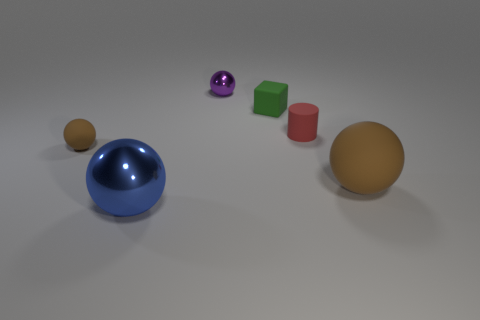Subtract all large shiny spheres. How many spheres are left? 3 Add 1 purple matte objects. How many objects exist? 7 Subtract all blue balls. How many balls are left? 3 Subtract 1 spheres. How many spheres are left? 3 Subtract 0 gray cylinders. How many objects are left? 6 Subtract all blocks. How many objects are left? 5 Subtract all red spheres. Subtract all gray cylinders. How many spheres are left? 4 Subtract all cyan cylinders. How many brown balls are left? 2 Subtract all blocks. Subtract all small objects. How many objects are left? 1 Add 5 tiny brown rubber objects. How many tiny brown rubber objects are left? 6 